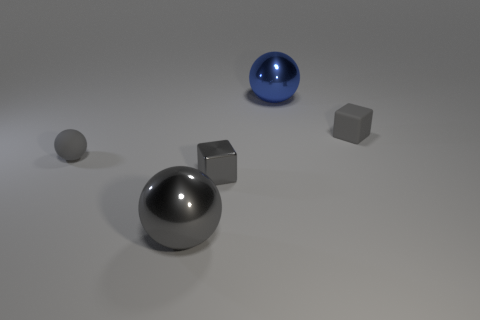There is a big blue object on the right side of the tiny gray metallic object; are there any large gray shiny spheres that are behind it?
Give a very brief answer. No. There is another small thing that is the same shape as the small gray metallic thing; what color is it?
Make the answer very short. Gray. How many other small shiny objects are the same color as the tiny shiny thing?
Give a very brief answer. 0. There is a block in front of the gray object that is to the left of the large sphere in front of the blue shiny ball; what is its color?
Ensure brevity in your answer.  Gray. Are the large gray sphere and the small sphere made of the same material?
Your answer should be compact. No. Do the large blue metal thing and the small metal thing have the same shape?
Your answer should be compact. No. Are there the same number of tiny cubes that are behind the tiny gray ball and tiny rubber things that are in front of the gray metal sphere?
Keep it short and to the point. No. There is a block that is the same material as the tiny ball; what color is it?
Keep it short and to the point. Gray. How many other small spheres are made of the same material as the blue ball?
Your answer should be very brief. 0. Is the color of the tiny thing that is on the left side of the big gray shiny object the same as the matte cube?
Give a very brief answer. Yes. 